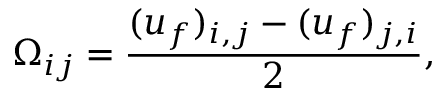<formula> <loc_0><loc_0><loc_500><loc_500>{ \Omega _ { i j } } = \frac { ( { u _ { f } ) _ { i , j } } - ( { u _ { f } ) _ { j , i } } } { 2 } ,</formula> 